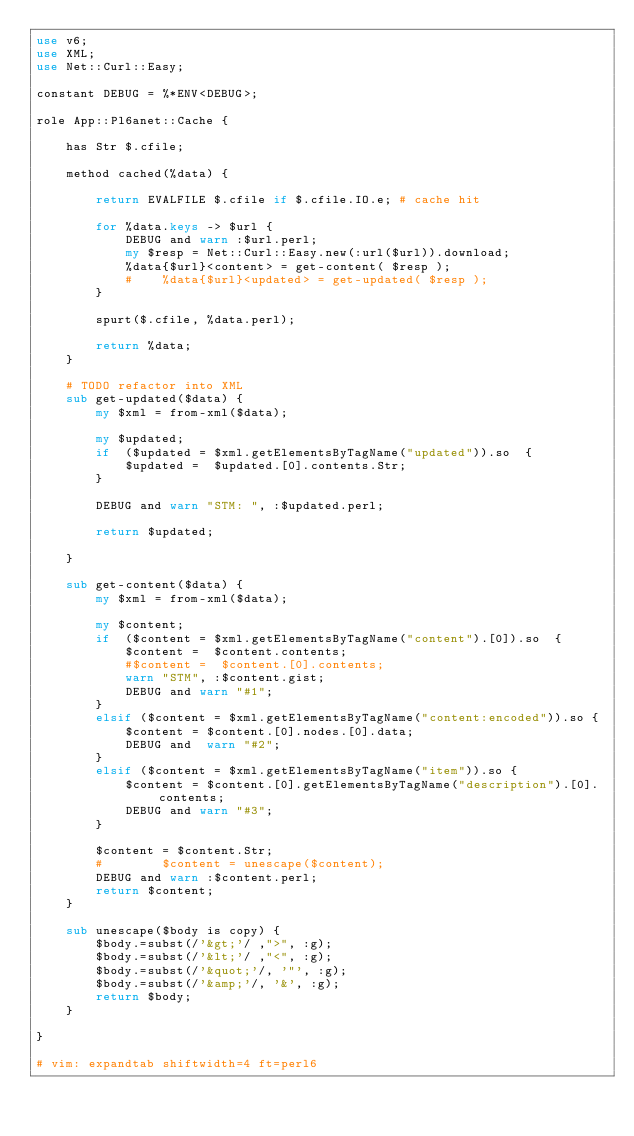Convert code to text. <code><loc_0><loc_0><loc_500><loc_500><_Perl_>use v6;
use XML;
use Net::Curl::Easy;

constant DEBUG = %*ENV<DEBUG>;

role App::Pl6anet::Cache {

    has Str $.cfile;

    method cached(%data) {

        return EVALFILE $.cfile if $.cfile.IO.e; # cache hit

        for %data.keys -> $url {
            DEBUG and warn :$url.perl;
            my $resp = Net::Curl::Easy.new(:url($url)).download;
            %data{$url}<content> = get-content( $resp );
            #    %data{$url}<updated> = get-updated( $resp );
        }

        spurt($.cfile, %data.perl);

        return %data;
    }

    # TODO refactor into XML
    sub get-updated($data) {
        my $xml = from-xml($data);

        my $updated;
        if  ($updated = $xml.getElementsByTagName("updated")).so  {
            $updated =  $updated.[0].contents.Str;
        } 

        DEBUG and warn "STM: ", :$updated.perl;

        return $updated;

    }

    sub get-content($data) {
        my $xml = from-xml($data);

        my $content;
        if  ($content = $xml.getElementsByTagName("content").[0]).so  {
            $content =  $content.contents;
            #$content =  $content.[0].contents;
            warn "STM", :$content.gist;
            DEBUG and warn "#1";
        } 
        elsif ($content = $xml.getElementsByTagName("content:encoded")).so {
            $content = $content.[0].nodes.[0].data;
            DEBUG and  warn "#2";
        }
        elsif ($content = $xml.getElementsByTagName("item")).so {
            $content = $content.[0].getElementsByTagName("description").[0].contents;
            DEBUG and warn "#3";
        }

        $content = $content.Str; 
        #        $content = unescape($content);
        DEBUG and warn :$content.perl;
        return $content;
    }

    sub unescape($body is copy) {
        $body.=subst(/'&gt;'/ ,">", :g);
        $body.=subst(/'&lt;'/ ,"<", :g);
        $body.=subst(/'&quot;'/, '"', :g);
        $body.=subst(/'&amp;'/, '&', :g);
        return $body;
    }

}

# vim: expandtab shiftwidth=4 ft=perl6
</code> 